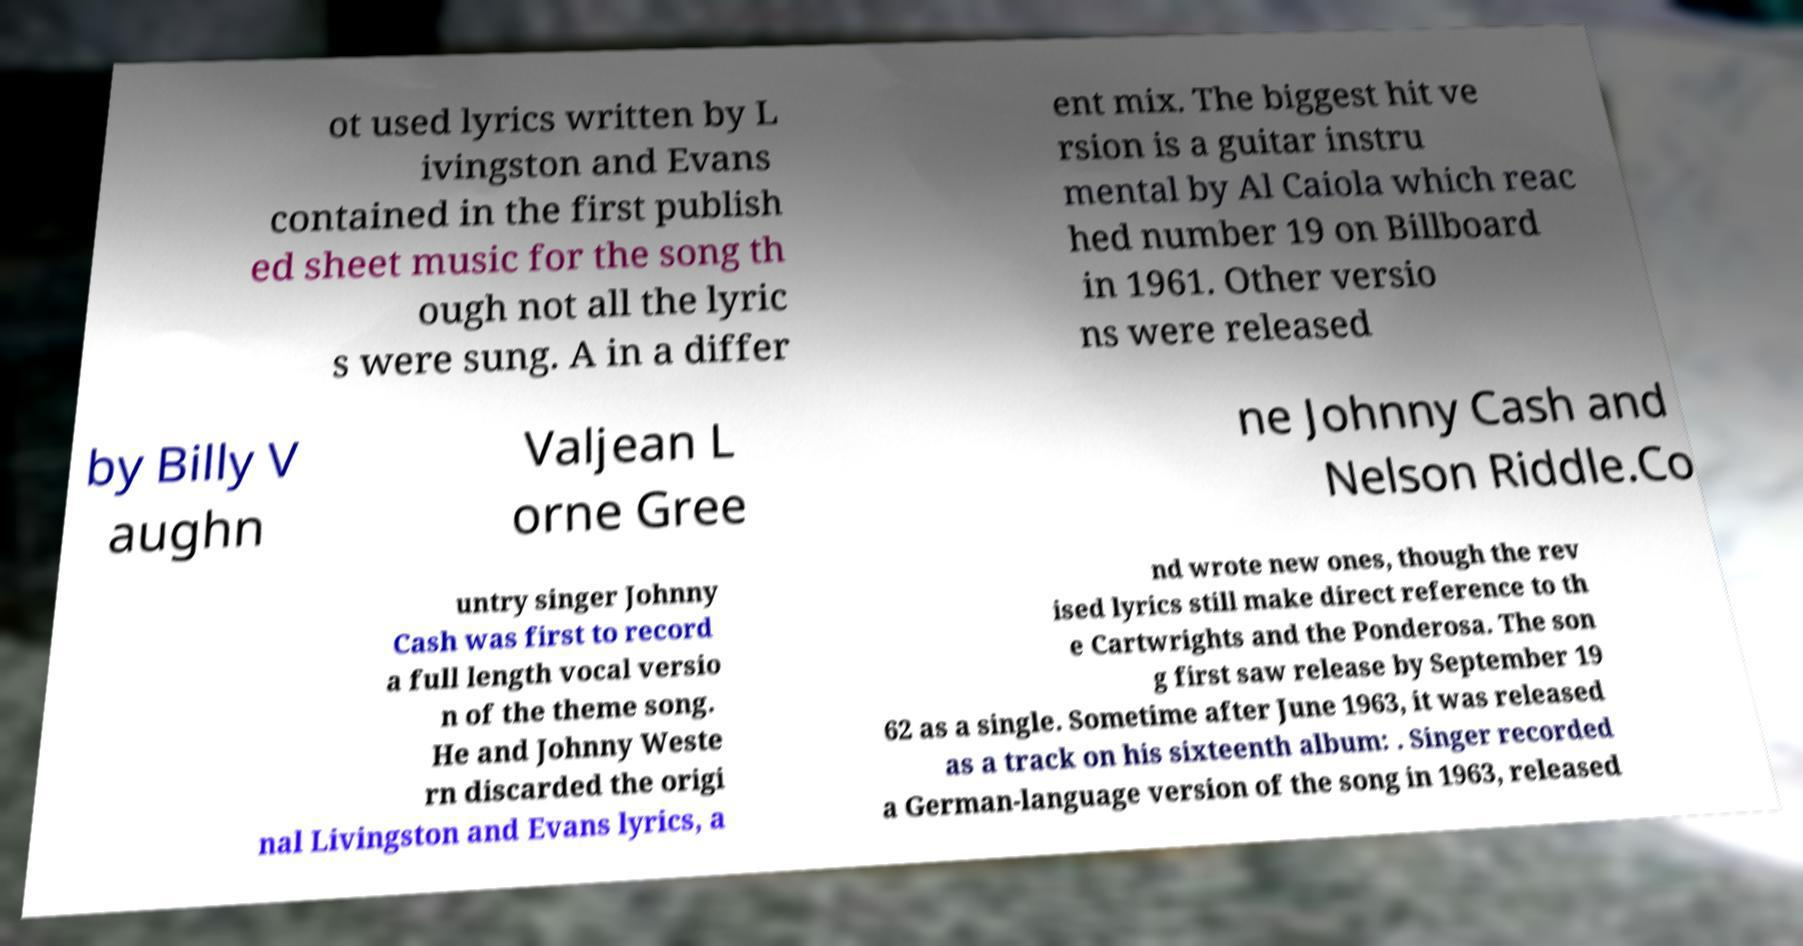There's text embedded in this image that I need extracted. Can you transcribe it verbatim? ot used lyrics written by L ivingston and Evans contained in the first publish ed sheet music for the song th ough not all the lyric s were sung. A in a differ ent mix. The biggest hit ve rsion is a guitar instru mental by Al Caiola which reac hed number 19 on Billboard in 1961. Other versio ns were released by Billy V aughn Valjean L orne Gree ne Johnny Cash and Nelson Riddle.Co untry singer Johnny Cash was first to record a full length vocal versio n of the theme song. He and Johnny Weste rn discarded the origi nal Livingston and Evans lyrics, a nd wrote new ones, though the rev ised lyrics still make direct reference to th e Cartwrights and the Ponderosa. The son g first saw release by September 19 62 as a single. Sometime after June 1963, it was released as a track on his sixteenth album: . Singer recorded a German-language version of the song in 1963, released 